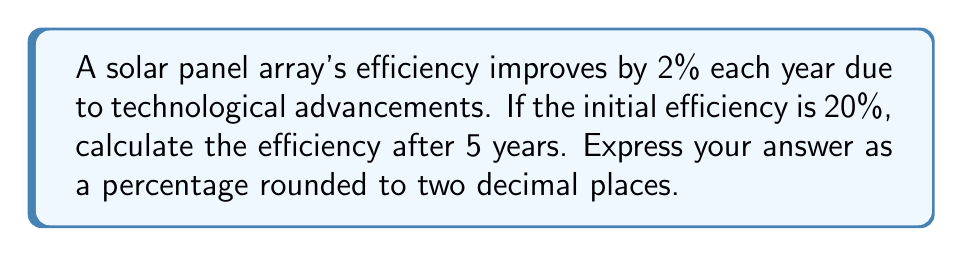Solve this math problem. Let's approach this step-by-step:

1) Initial efficiency: 20%

2) Yearly improvement: 2% of the previous year's efficiency

3) We need to calculate this for 5 years:

   Year 1: $20\% \times (1 + 0.02) = 20\% \times 1.02 = 20.40\%$
   
   Year 2: $20.40\% \times 1.02 = 20.808\%$
   
   Year 3: $20.808\% \times 1.02 = 21.22416\%$
   
   Year 4: $21.22416\% \times 1.02 = 21.6486432\%$
   
   Year 5: $21.6486432\% \times 1.02 = 22.08161606\%$

4) Rounding to two decimal places: 22.08%

Alternatively, we can use the compound interest formula:

$$A = P(1 + r)^n$$

Where:
A = Final amount
P = Principal amount (initial efficiency)
r = Rate of increase (as a decimal)
n = Number of compounding periods (years)

$$A = 20\%(1 + 0.02)^5 = 20\% \times 1.10408 = 22.08161606\%$$

Rounding to two decimal places gives us 22.08%.
Answer: 22.08% 